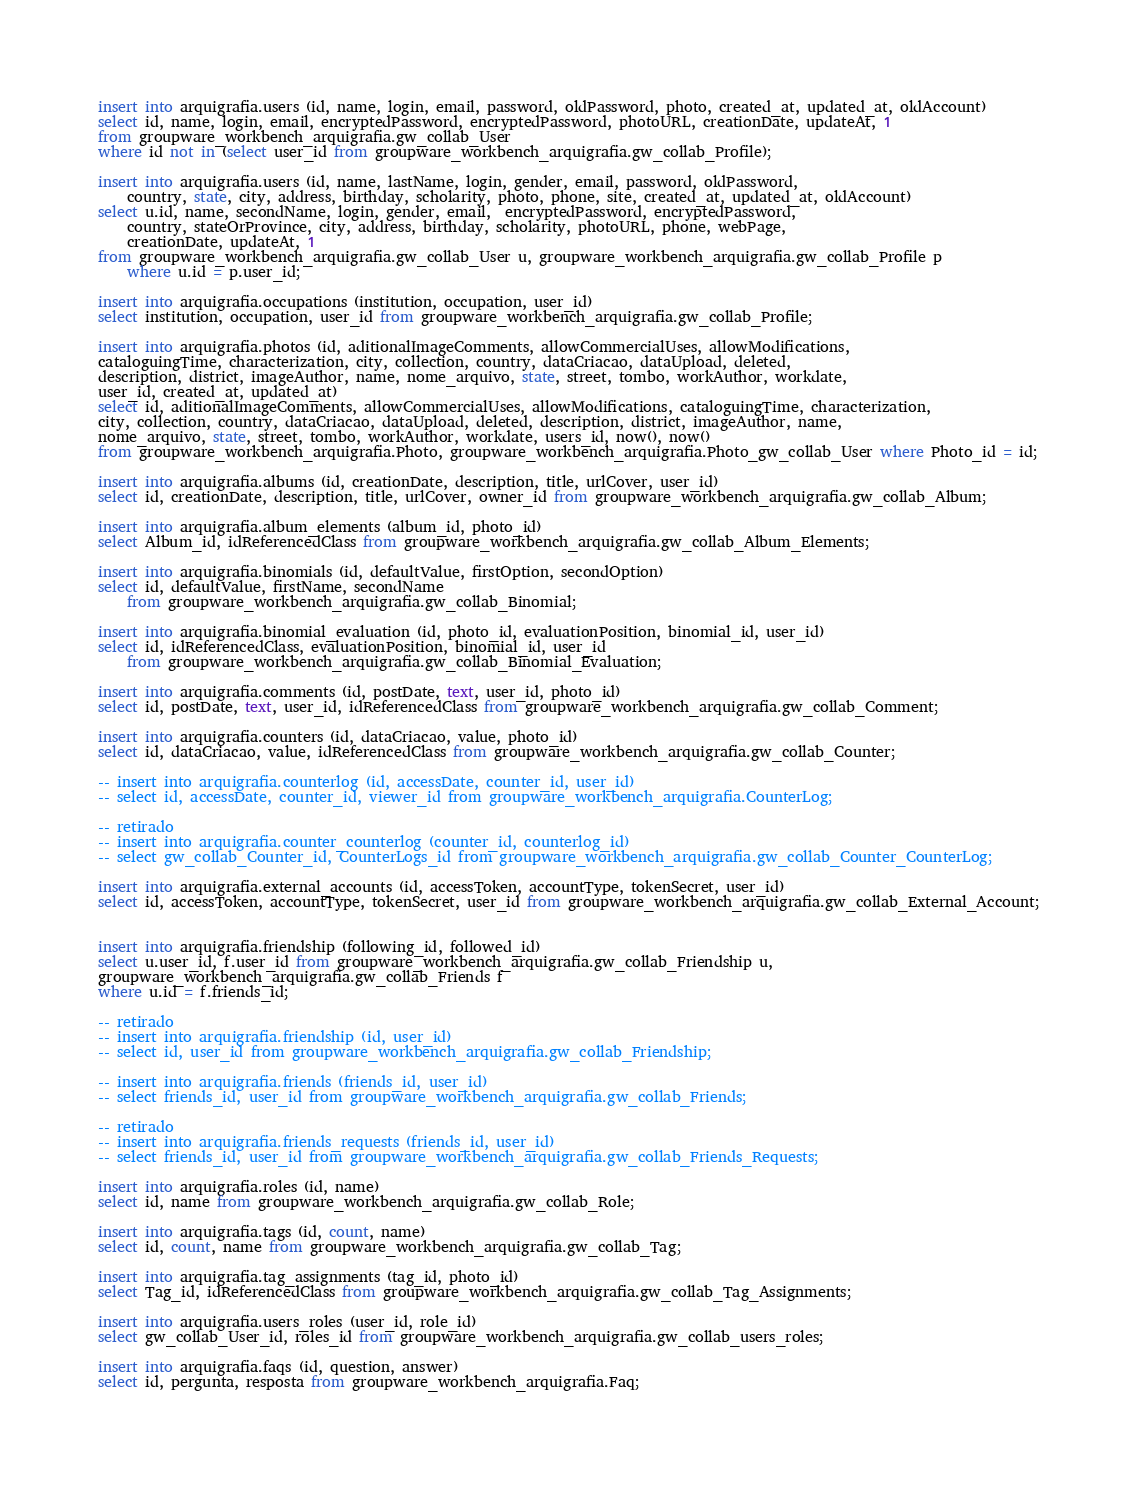<code> <loc_0><loc_0><loc_500><loc_500><_SQL_>insert into arquigrafia.users (id, name, login, email, password, oldPassword, photo, created_at, updated_at, oldAccount)
select id, name, login, email, encryptedPassword, encryptedPassword, photoURL, creationDate, updateAt, 1
from groupware_workbench_arquigrafia.gw_collab_User 
where id not in (select user_id from groupware_workbench_arquigrafia.gw_collab_Profile);

insert into arquigrafia.users (id, name, lastName, login, gender, email, password, oldPassword, 
	country, state, city, address, birthday, scholarity, photo, phone, site, created_at, updated_at, oldAccount)
select u.id, name, secondName, login, gender, email,  encryptedPassword, encryptedPassword, 
	country, stateOrProvince, city, address, birthday, scholarity, photoURL, phone, webPage, 
	creationDate, updateAt, 1
from groupware_workbench_arquigrafia.gw_collab_User u, groupware_workbench_arquigrafia.gw_collab_Profile p
	where u.id = p.user_id;

insert into arquigrafia.occupations (institution, occupation, user_id)
select institution, occupation, user_id from groupware_workbench_arquigrafia.gw_collab_Profile;

insert into arquigrafia.photos (id, aditionalImageComments, allowCommercialUses, allowModifications, 
cataloguingTime, characterization, city, collection, country, dataCriacao, dataUpload, deleted, 
description, district, imageAuthor, name, nome_arquivo, state, street, tombo, workAuthor, workdate, 
user_id, created_at, updated_at)
select id, aditionalImageComments, allowCommercialUses, allowModifications, cataloguingTime, characterization, 
city, collection, country, dataCriacao, dataUpload, deleted, description, district, imageAuthor, name, 
nome_arquivo, state, street, tombo, workAuthor, workdate, users_id, now(), now() 
from groupware_workbench_arquigrafia.Photo, groupware_workbench_arquigrafia.Photo_gw_collab_User where Photo_id = id;

insert into arquigrafia.albums (id, creationDate, description, title, urlCover, user_id)
select id, creationDate, description, title, urlCover, owner_id from groupware_workbench_arquigrafia.gw_collab_Album;

insert into arquigrafia.album_elements (album_id, photo_id)
select Album_id, idReferencedClass from groupware_workbench_arquigrafia.gw_collab_Album_Elements;

insert into arquigrafia.binomials (id, defaultValue, firstOption, secondOption)
select id, defaultValue, firstName, secondName 
	from groupware_workbench_arquigrafia.gw_collab_Binomial;

insert into arquigrafia.binomial_evaluation (id, photo_id, evaluationPosition, binomial_id, user_id)
select id, idReferencedClass, evaluationPosition, binomial_id, user_id 
	from groupware_workbench_arquigrafia.gw_collab_Binomial_Evaluation;

insert into arquigrafia.comments (id, postDate, text, user_id, photo_id)
select id, postDate, text, user_id, idReferencedClass from groupware_workbench_arquigrafia.gw_collab_Comment;

insert into arquigrafia.counters (id, dataCriacao, value, photo_id)
select id, dataCriacao, value, idReferencedClass from groupware_workbench_arquigrafia.gw_collab_Counter;

-- insert into arquigrafia.counterlog (id, accessDate, counter_id, user_id)
-- select id, accessDate, counter_id, viewer_id from groupware_workbench_arquigrafia.CounterLog;

-- retirado
-- insert into arquigrafia.counter_counterlog (counter_id, counterlog_id)
-- select gw_collab_Counter_id, CounterLogs_id from groupware_workbench_arquigrafia.gw_collab_Counter_CounterLog;

insert into arquigrafia.external_accounts (id, accessToken, accountType, tokenSecret, user_id)
select id, accessToken, accountType, tokenSecret, user_id from groupware_workbench_arquigrafia.gw_collab_External_Account;


insert into arquigrafia.friendship (following_id, followed_id)
select u.user_id, f.user_id from groupware_workbench_arquigrafia.gw_collab_Friendship u, 
groupware_workbench_arquigrafia.gw_collab_Friends f
where u.id = f.friends_id;

-- retirado
-- insert into arquigrafia.friendship (id, user_id)
-- select id, user_id from groupware_workbench_arquigrafia.gw_collab_Friendship;

-- insert into arquigrafia.friends (friends_id, user_id)
-- select friends_id, user_id from groupware_workbench_arquigrafia.gw_collab_Friends;

-- retirado
-- insert into arquigrafia.friends_requests (friends_id, user_id)
-- select friends_id, user_id from groupware_workbench_arquigrafia.gw_collab_Friends_Requests;

insert into arquigrafia.roles (id, name)
select id, name from groupware_workbench_arquigrafia.gw_collab_Role;

insert into arquigrafia.tags (id, count, name)
select id, count, name from groupware_workbench_arquigrafia.gw_collab_Tag;

insert into arquigrafia.tag_assignments (tag_id, photo_id)
select Tag_id, idReferencedClass from groupware_workbench_arquigrafia.gw_collab_Tag_Assignments;

insert into arquigrafia.users_roles (user_id, role_id)
select gw_collab_User_id, roles_id from groupware_workbench_arquigrafia.gw_collab_users_roles;

insert into arquigrafia.faqs (id, question, answer)
select id, pergunta, resposta from groupware_workbench_arquigrafia.Faq;</code> 